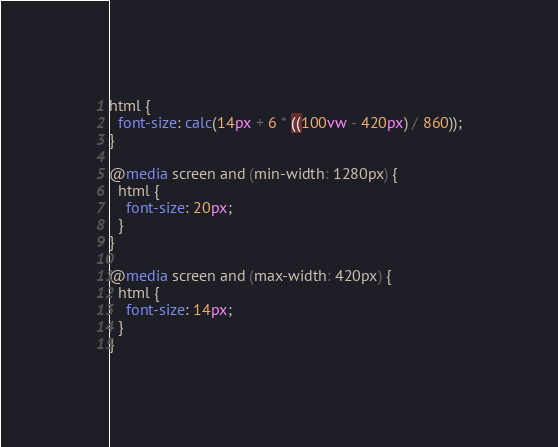Convert code to text. <code><loc_0><loc_0><loc_500><loc_500><_CSS_>html {
  font-size: calc(14px + 6 * ((100vw - 420px) / 860));
}

@media screen and (min-width: 1280px) {
  html {
    font-size: 20px;
  }
}

@media screen and (max-width: 420px) {
  html {
    font-size: 14px;
  }
}
</code> 